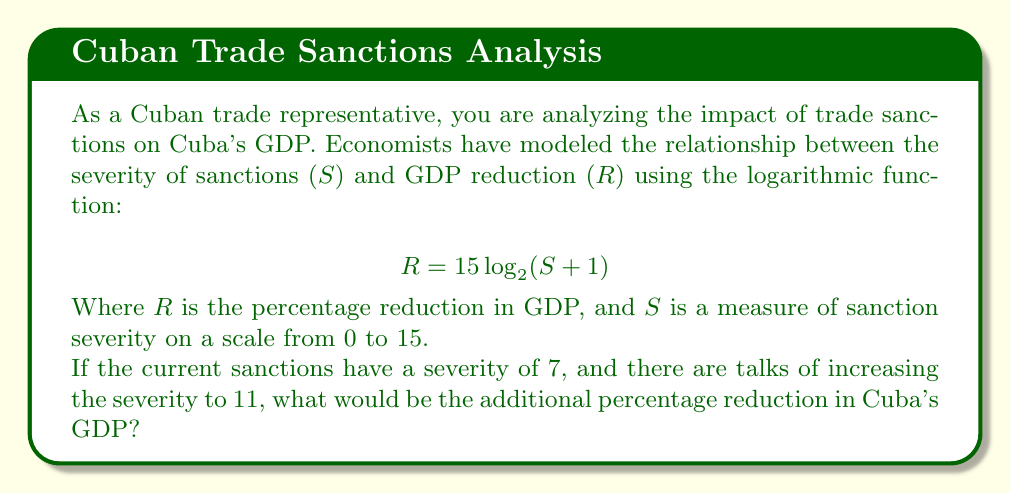Give your solution to this math problem. To solve this problem, we need to:
1. Calculate the current GDP reduction at severity 7
2. Calculate the potential GDP reduction at severity 11
3. Find the difference between these two values

Step 1: Current GDP reduction (S = 7)
$$ R_1 = 15 \log_2(7 + 1) = 15 \log_2(8) = 15 \cdot 3 = 45\% $$

Step 2: Potential GDP reduction (S = 11)
$$ R_2 = 15 log_2(11 + 1) = 15 \log_2(12) \approx 15 \cdot 3.58 \approx 53.7\% $$

Step 3: Additional GDP reduction
$$ \text{Additional Reduction} = R_2 - R_1 \approx 53.7\% - 45\% = 8.7\% $$

Therefore, the additional percentage reduction in Cuba's GDP would be approximately 8.7%.
Answer: The additional percentage reduction in Cuba's GDP would be approximately 8.7%. 